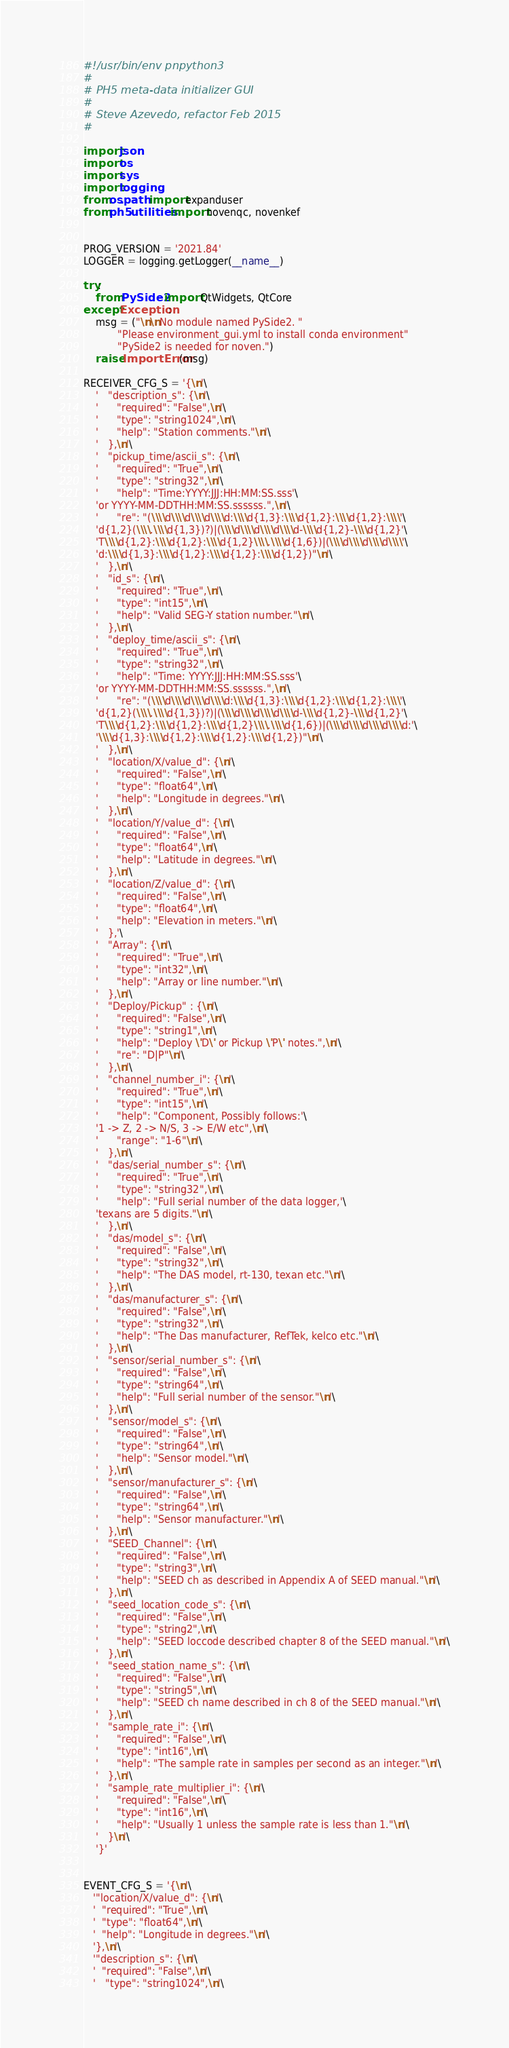Convert code to text. <code><loc_0><loc_0><loc_500><loc_500><_Python_>#!/usr/bin/env pnpython3
#
# PH5 meta-data initializer GUI
#
# Steve Azevedo, refactor Feb 2015
#

import json
import os
import sys
import logging
from os.path import expanduser
from ph5.utilities import novenqc, novenkef


PROG_VERSION = '2021.84'
LOGGER = logging.getLogger(__name__)

try:
    from PySide2 import QtWidgets, QtCore
except Exception:
    msg = ("\n\nNo module named PySide2. "
           "Please environment_gui.yml to install conda environment"
           "PySide2 is needed for noven.")
    raise ImportError(msg)

RECEIVER_CFG_S = '{\n'\
    '   "description_s": {\n'\
    '      "required": "False",\n'\
    '      "type": "string1024",\n'\
    '      "help": "Station comments."\n'\
    '   },\n'\
    '   "pickup_time/ascii_s": {\n'\
    '      "required": "True",\n'\
    '      "type": "string32",\n'\
    '      "help": "Time:YYYY:JJJ:HH:MM:SS.sss'\
    'or YYYY-MM-DDTHH:MM:SS.ssssss.",\n'\
    '      "re": "(\\\\d\\\\d\\\\d\\\\d:\\\\d{1,3}:\\\\d{1,2}:\\\\d{1,2}:\\\\'\
    'd{1,2}(\\\\.\\\\d{1,3})?)|(\\\\d\\\\d\\\\d\\\\d-\\\\d{1,2}-\\\\d{1,2}'\
    'T\\\\d{1,2}:\\\\d{1,2}:\\\\d{1,2}\\\\.\\\\d{1,6})|(\\\\d\\\\d\\\\d\\\\'\
    'd:\\\\d{1,3}:\\\\d{1,2}:\\\\d{1,2}:\\\\d{1,2})"\n'\
    '   },\n'\
    '   "id_s": {\n'\
    '      "required": "True",\n'\
    '      "type": "int15",\n'\
    '      "help": "Valid SEG-Y station number."\n'\
    '   },\n'\
    '   "deploy_time/ascii_s": {\n'\
    '      "required": "True",\n'\
    '      "type": "string32",\n'\
    '      "help": "Time: YYYY:JJJ:HH:MM:SS.sss'\
    'or YYYY-MM-DDTHH:MM:SS.ssssss.",\n'\
    '      "re": "(\\\\d\\\\d\\\\d\\\\d:\\\\d{1,3}:\\\\d{1,2}:\\\\d{1,2}:\\\\'\
    'd{1,2}(\\\\.\\\\d{1,3})?)|(\\\\d\\\\d\\\\d\\\\d-\\\\d{1,2}-\\\\d{1,2}'\
    'T\\\\d{1,2}:\\\\d{1,2}:\\\\d{1,2}\\\\.\\\\d{1,6})|(\\\\d\\\\d\\\\d\\\\d:'\
    '\\\\d{1,3}:\\\\d{1,2}:\\\\d{1,2}:\\\\d{1,2})"\n'\
    '   },\n'\
    '   "location/X/value_d": {\n'\
    '      "required": "False",\n'\
    '      "type": "float64",\n'\
    '      "help": "Longitude in degrees."\n'\
    '   },\n'\
    '   "location/Y/value_d": {\n'\
    '      "required": "False",\n'\
    '      "type": "float64",\n'\
    '      "help": "Latitude in degrees."\n'\
    '   },\n'\
    '   "location/Z/value_d": {\n'\
    '      "required": "False",\n'\
    '      "type": "float64",\n'\
    '      "help": "Elevation in meters."\n'\
    '   },'\
    '   "Array": {\n'\
    '      "required": "True",\n'\
    '      "type": "int32",\n'\
    '      "help": "Array or line number."\n'\
    '   },\n'\
    '   "Deploy/Pickup" : {\n'\
    '      "required": "False",\n'\
    '      "type": "string1",\n'\
    '      "help": "Deploy \'D\' or Pickup \'P\' notes.",\n'\
    '      "re": "D|P"\n'\
    '   },\n'\
    '   "channel_number_i": {\n'\
    '      "required": "True",\n'\
    '      "type": "int15",\n'\
    '      "help": "Component, Possibly follows:'\
    '1 -> Z, 2 -> N/S, 3 -> E/W etc",\n'\
    '      "range": "1-6"\n'\
    '   },\n'\
    '   "das/serial_number_s": {\n'\
    '      "required": "True",\n'\
    '      "type": "string32",\n'\
    '      "help": "Full serial number of the data logger,'\
    'texans are 5 digits."\n'\
    '   },\n'\
    '   "das/model_s": {\n'\
    '      "required": "False",\n'\
    '      "type": "string32",\n'\
    '      "help": "The DAS model, rt-130, texan etc."\n'\
    '   },\n'\
    '   "das/manufacturer_s": {\n'\
    '      "required": "False",\n'\
    '      "type": "string32",\n'\
    '      "help": "The Das manufacturer, RefTek, kelco etc."\n'\
    '   },\n'\
    '   "sensor/serial_number_s": {\n'\
    '      "required": "False",\n'\
    '      "type": "string64",\n'\
    '      "help": "Full serial number of the sensor."\n'\
    '   },\n'\
    '   "sensor/model_s": {\n'\
    '      "required": "False",\n'\
    '      "type": "string64",\n'\
    '      "help": "Sensor model."\n'\
    '   },\n'\
    '   "sensor/manufacturer_s": {\n'\
    '      "required": "False",\n'\
    '      "type": "string64",\n'\
    '      "help": "Sensor manufacturer."\n'\
    '   },\n'\
    '   "SEED_Channel": {\n'\
    '      "required": "False",\n'\
    '      "type": "string3",\n'\
    '      "help": "SEED ch as described in Appendix A of SEED manual."\n'\
    '   },\n'\
    '   "seed_location_code_s": {\n'\
    '      "required": "False",\n'\
    '      "type": "string2",\n'\
    '      "help": "SEED loccode described chapter 8 of the SEED manual."\n'\
    '   },\n'\
    '   "seed_station_name_s": {\n'\
    '      "required": "False",\n'\
    '      "type": "string5",\n'\
    '      "help": "SEED ch name described in ch 8 of the SEED manual."\n'\
    '   },\n'\
    '   "sample_rate_i": {\n'\
    '      "required": "False",\n'\
    '      "type": "int16",\n'\
    '      "help": "The sample rate in samples per second as an integer."\n'\
    '   },\n'\
    '   "sample_rate_multiplier_i": {\n'\
    '      "required": "False",\n'\
    '      "type": "int16",\n'\
    '      "help": "Usually 1 unless the sample rate is less than 1."\n'\
    '   }\n'\
    '}'


EVENT_CFG_S = '{\n'\
   '"location/X/value_d": {\n'\
   '  "required": "True",\n'\
   '  "type": "float64",\n'\
   '  "help": "Longitude in degrees."\n'\
   '},\n'\
   '"description_s": {\n'\
   '  "required": "False",\n'\
   '   "type": "string1024",\n'\</code> 